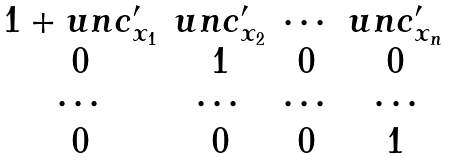Convert formula to latex. <formula><loc_0><loc_0><loc_500><loc_500>\begin{matrix} 1 + u n c ^ { \prime } _ { x _ { 1 } } & u n c ^ { \prime } _ { x _ { 2 } } & \cdots & u n c ^ { \prime } _ { x _ { n } } \\ 0 & 1 & 0 & 0 \\ \cdots & \cdots & \cdots & \cdots \\ 0 & 0 & 0 & 1 \end{matrix}</formula> 